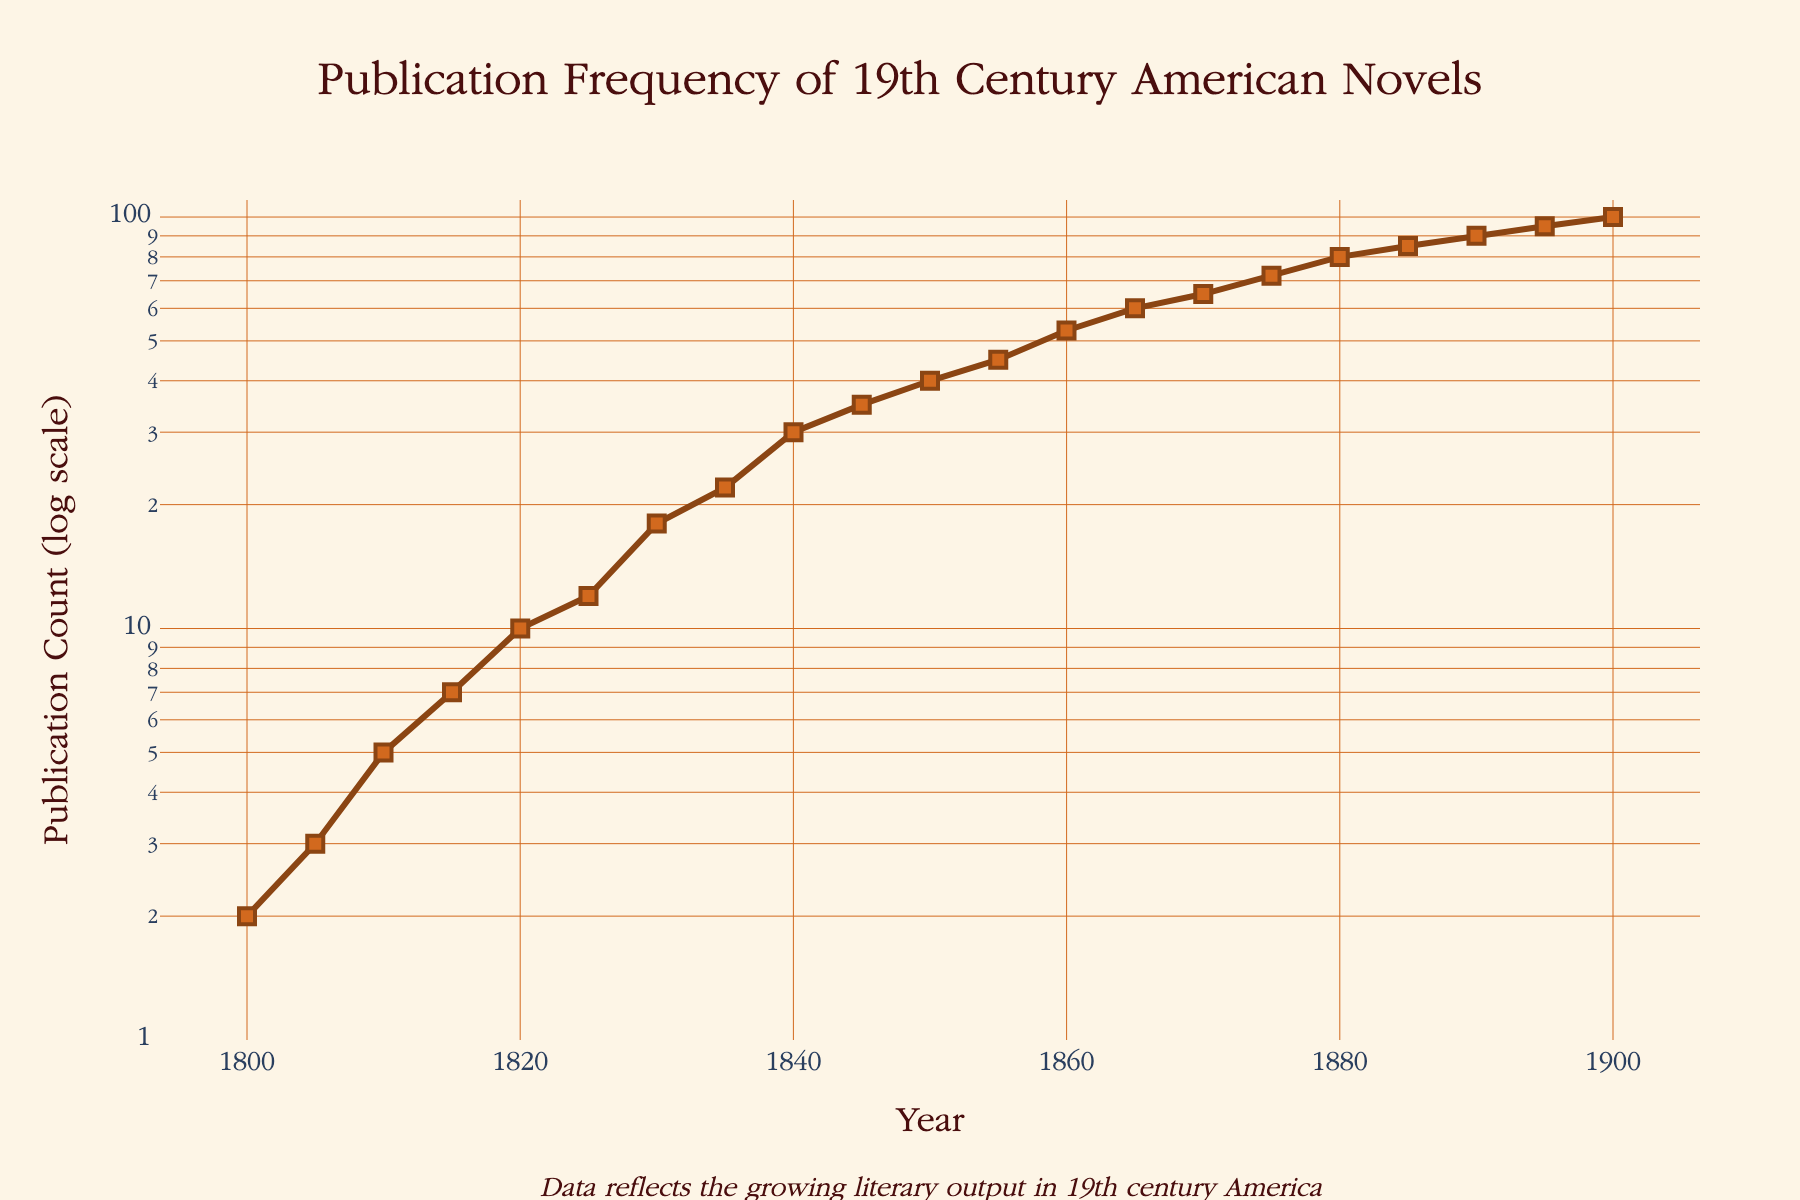What is the title of the figure? The title of the figure is prominently displayed at the top and notes the focus of the plot.
Answer: Publication Frequency of 19th Century American Novels How many data points are shown in the plot? Count each marker in the figure. The markers represent each recorded year in the data set.
Answer: 21 Which year shows a publication count of 40? Locate the year corresponding to the publication count value of 40 on the y-axis.
Answer: 1850 How does the publication count change between 1840 and 1855? Subtract the publication count in 1840 (30) from the publication count in 1855 (45).
Answer: Increases by 15 Which year had the highest publication count in the 19th century? Identify the highest publication count on the y-axis and find the corresponding year on the x-axis.
Answer: 1900 How many publications were there in 1835? Locate the publication count for the year 1835 on the x-axis.
Answer: 22 What is the relative growth in publication count from 1820 to 1870? The publication count in 1820 is 10 and in 1870 is 65. The relative growth is calculated as (65 - 10) / 10.
Answer: 5.5 Compare the rate of publication growth from 1800 to 1820 with the growth from 1865 to 1900. Which period had a higher increase? Calculate the increase from 1800 to 1820 (10 - 2 = 8) and from 1865 to 1900 (100 - 60 = 40). Compare the two values.
Answer: 1865 to 1900 In what range of years did the publication count increase most rapidly? Identify the years with the steepest slope on the plot, indicating the fastest growth.
Answer: 1860-1900 What is the change in publication count between 1860 and 1880? Subtract the publication count in 1860 (53) from the publication count in 1880 (80).
Answer: 27 